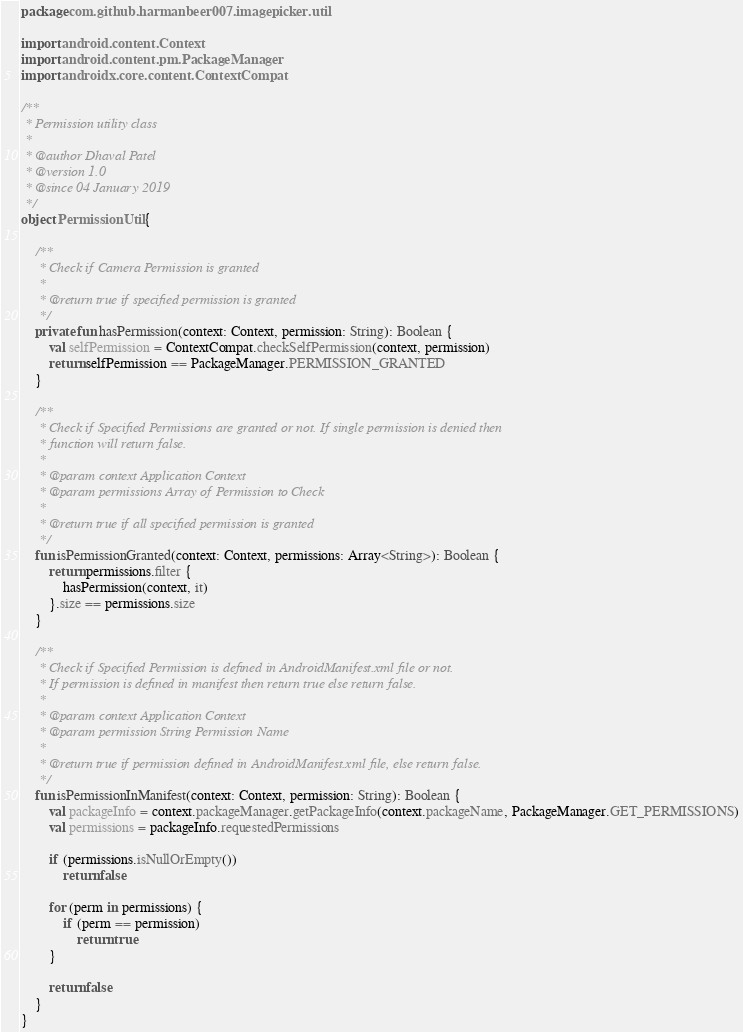Convert code to text. <code><loc_0><loc_0><loc_500><loc_500><_Kotlin_>package com.github.harmanbeer007.imagepicker.util

import android.content.Context
import android.content.pm.PackageManager
import androidx.core.content.ContextCompat

/**
 * Permission utility class
 *
 * @author Dhaval Patel
 * @version 1.0
 * @since 04 January 2019
 */
object PermissionUtil {

    /**
     * Check if Camera Permission is granted
     *
     * @return true if specified permission is granted
     */
    private fun hasPermission(context: Context, permission: String): Boolean {
        val selfPermission = ContextCompat.checkSelfPermission(context, permission)
        return selfPermission == PackageManager.PERMISSION_GRANTED
    }

    /**
     * Check if Specified Permissions are granted or not. If single permission is denied then
     * function will return false.
     *
     * @param context Application Context
     * @param permissions Array of Permission to Check
     *
     * @return true if all specified permission is granted
     */
    fun isPermissionGranted(context: Context, permissions: Array<String>): Boolean {
        return permissions.filter {
            hasPermission(context, it)
        }.size == permissions.size
    }

    /**
     * Check if Specified Permission is defined in AndroidManifest.xml file or not.
     * If permission is defined in manifest then return true else return false.
     *
     * @param context Application Context
     * @param permission String Permission Name
     *
     * @return true if permission defined in AndroidManifest.xml file, else return false.
     */
    fun isPermissionInManifest(context: Context, permission: String): Boolean {
        val packageInfo = context.packageManager.getPackageInfo(context.packageName, PackageManager.GET_PERMISSIONS)
        val permissions = packageInfo.requestedPermissions

        if (permissions.isNullOrEmpty())
            return false

        for (perm in permissions) {
            if (perm == permission)
                return true
        }

        return false
    }
}
</code> 